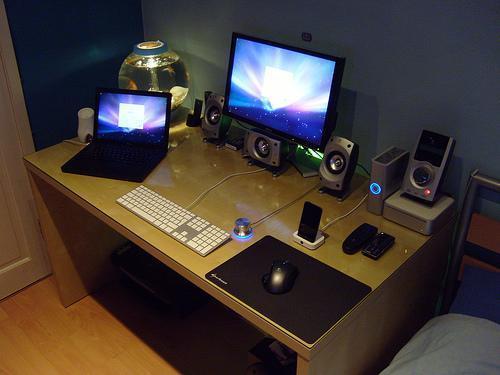How many desks are there?
Give a very brief answer. 1. 